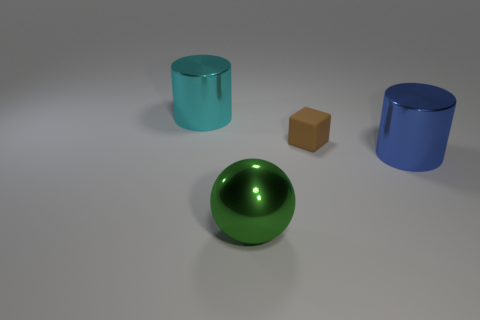Add 1 rubber spheres. How many objects exist? 5 Subtract all balls. How many objects are left? 3 Subtract 0 gray balls. How many objects are left? 4 Subtract all tiny red cubes. Subtract all brown cubes. How many objects are left? 3 Add 2 tiny cubes. How many tiny cubes are left? 3 Add 4 large brown metal spheres. How many large brown metal spheres exist? 4 